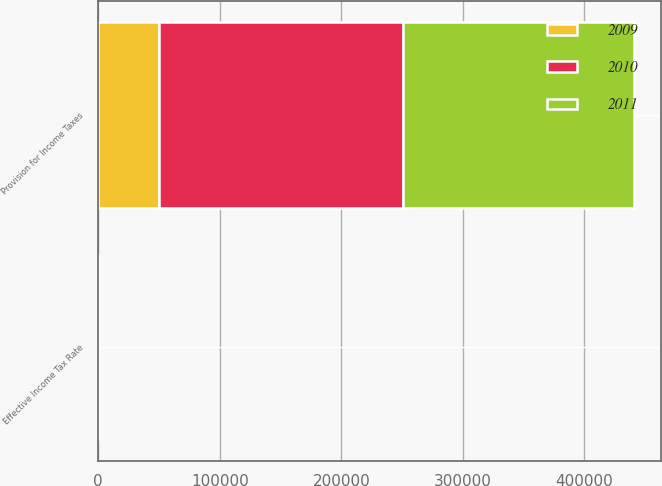<chart> <loc_0><loc_0><loc_500><loc_500><stacked_bar_chart><ecel><fcel>Provision for Income Taxes<fcel>Effective Income Tax Rate<nl><fcel>2010<fcel>200553<fcel>18.9<nl><fcel>2011<fcel>190440<fcel>21.1<nl><fcel>2009<fcel>50036<fcel>16.8<nl></chart> 